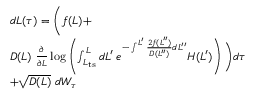<formula> <loc_0><loc_0><loc_500><loc_500>\begin{array} { r l } & { d L ( \tau ) = \left ( f ( L ) + } \\ & { D ( L ) \ \frac { \partial } { \partial L } \log \left ( \int _ { L _ { t s } } ^ { L } d L ^ { \prime } \, e ^ { - \int ^ { L ^ { \prime } } \frac { 2 f ( L ^ { \prime \prime } ) } { D ( L ^ { \prime \prime } ) } d L ^ { \prime \prime } } H ( L ^ { \prime } ) \right ) \right ) d \tau } \\ & { + \sqrt { D ( L ) } \ d W _ { \tau } } \end{array}</formula> 